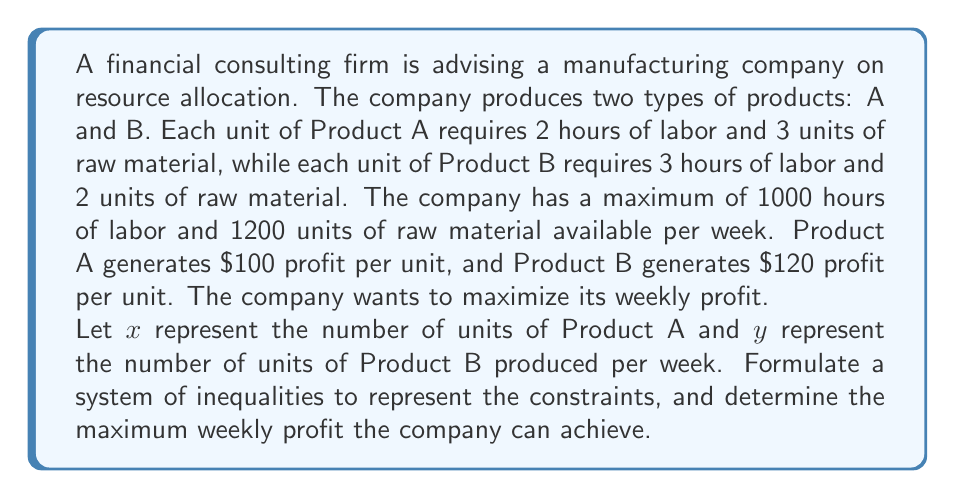Can you solve this math problem? Step 1: Formulate the system of inequalities
- Labor constraint: $2x + 3y \leq 1000$
- Raw material constraint: $3x + 2y \leq 1200$
- Non-negativity constraints: $x \geq 0$, $y \geq 0$

Step 2: Set up the profit function
Profit function: $P = 100x + 120y$

Step 3: Graph the inequalities
[asy]
size(200);
draw((0,0)--(600,0),arrow=Arrow(6));
draw((0,0)--(0,400),arrow=Arrow(6));
label("x",(600,0),E);
label("y",(0,400),N);
draw((0,333.33)--(500,0),blue);
draw((0,600)--(400,0),red);
label("2x + 3y = 1000",(250,166),NW,blue);
label("3x + 2y = 1200",(200,300),SE,red);
fill((0,0)--(0,333.33)--(300,200)--(400,0)--cycle,lightgray);
dot((0,333.33));
dot((400,0));
dot((300,200));
label("(0,333.33)",(0,333.33),W);
label("(400,0)",(400,0),S);
label("(300,200)",(300,200),NE);
[/asy]

Step 4: Identify the corner points
The feasible region is bounded by the constraints, forming a polygon. The optimal solution will be at one of the corner points:
(0, 0), (0, 333.33), (300, 200), (400, 0)

Step 5: Evaluate the profit function at each corner point
- P(0, 0) = $0
- P(0, 333.33) = $39,999.60
- P(300, 200) = $54,000
- P(400, 0) = $40,000

Step 6: Determine the maximum profit
The maximum profit occurs at the point (300, 200), which represents producing 300 units of Product A and 200 units of Product B per week.

Maximum profit = $54,000 per week
Answer: $54,000 per week 